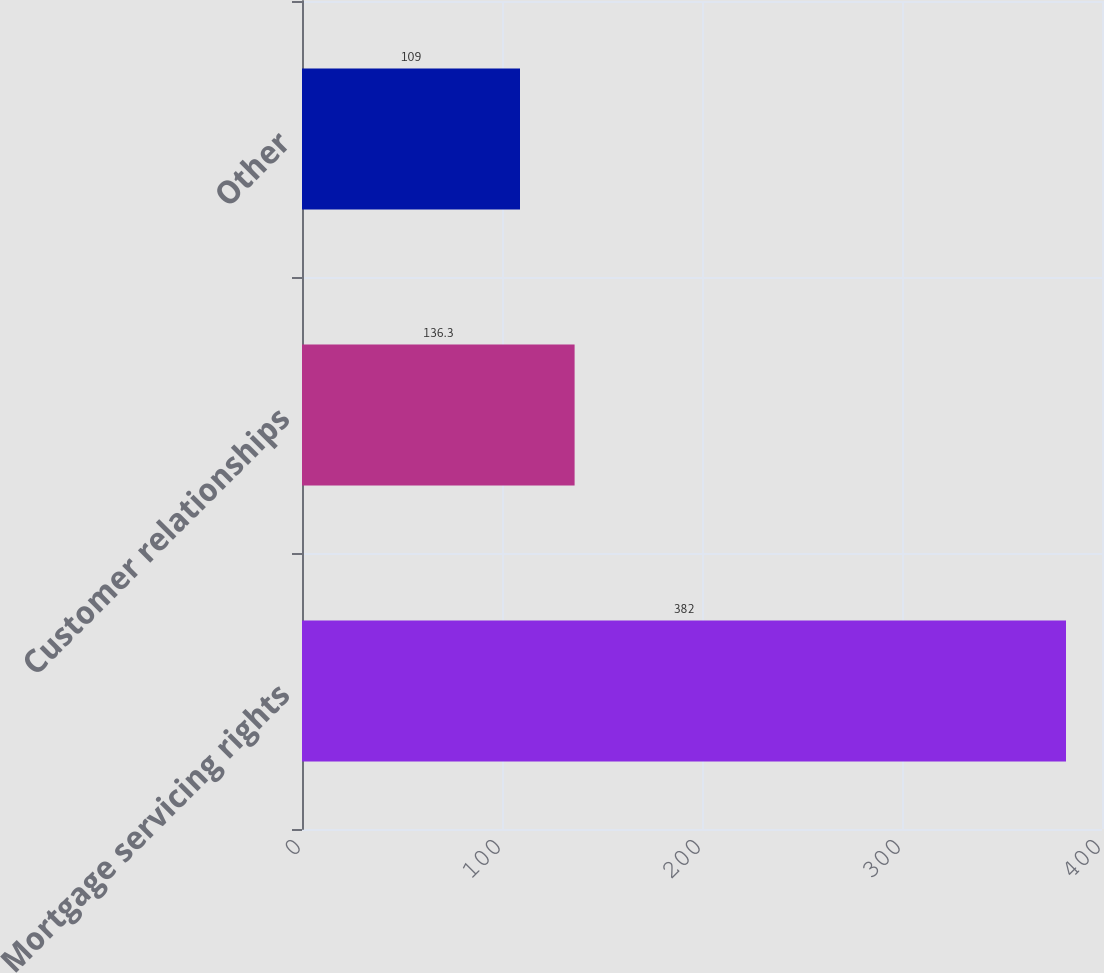<chart> <loc_0><loc_0><loc_500><loc_500><bar_chart><fcel>Mortgage servicing rights<fcel>Customer relationships<fcel>Other<nl><fcel>382<fcel>136.3<fcel>109<nl></chart> 